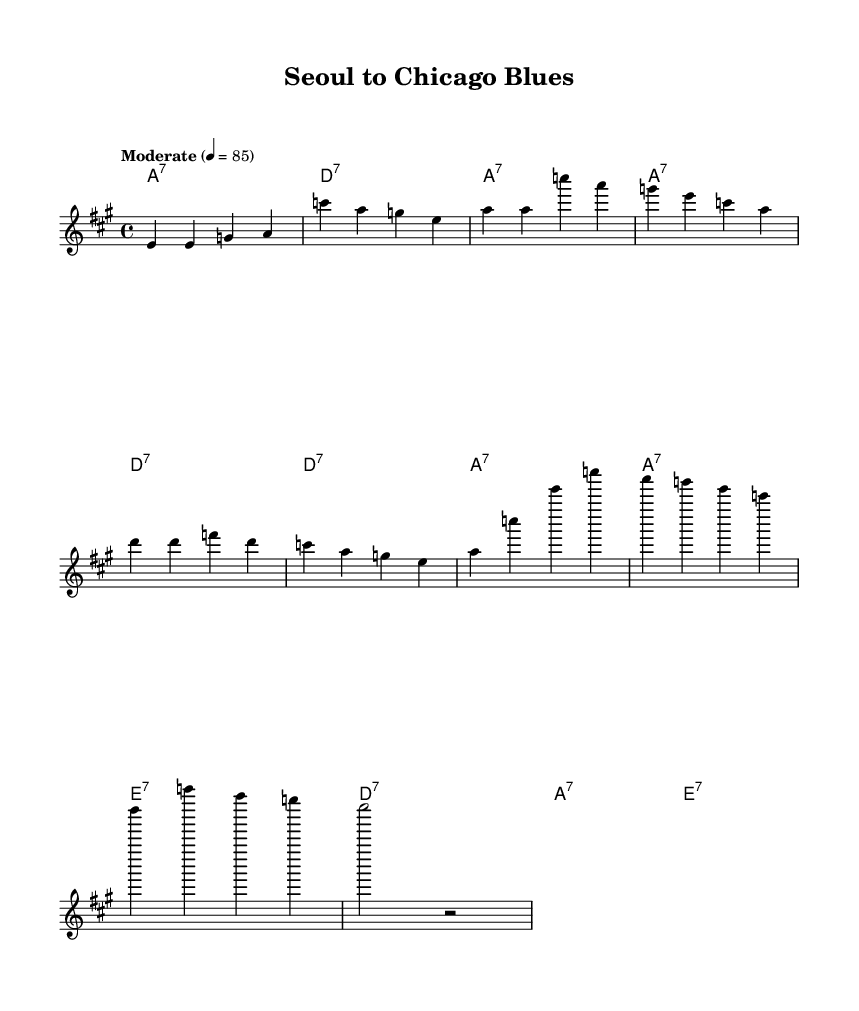What is the key signature of this music? The key signature is indicated in the global block of the code, which states "\key a \major." This means that there are three sharps in the key of A major.
Answer: A major What is the time signature of this piece? The time signature is also defined in the global block, specified as "\time 4/4." This indicates that there are four beats in a measure, and the quarter note gets one beat.
Answer: 4/4 What is the tempo marking for the music? The tempo is specified as "Moderate" with a beats per minute (BPM) marking of "4 = 85." This indicates how fast the music should be played, with 85 beats per minute.
Answer: 85 How many measures are in the chorus section? By counting the measures in the chorus lyrics section, we can see the total. "Chi -- ca -- go blues..." and the other lines make up four measures of music.
Answer: 4 What is the primary lyrical theme of the song? The lyrics express themes of displacement and perseverance, highlighting the challenges of urban life in Chicago while reflecting on a journey from Seoul. This is evident in both verses and the chorus content.
Answer: Urban life hardships What type of chord progression is used in the harmonies? The chord progression follows the typical twelve-bar blues format, alternating between A7, D7, and E7 chords. This is characteristic of the blues genre, often featuring dominant seventh chords that create a sense of tension and resolution.
Answer: Twelve-bar blues How does the melody relate to the lyrics? The melody is constructed to match the rhythmic phrasing of the lyrics, aligning syllables with notes. Each segment of lyrics corresponds to specific melodic phrases, facilitating expression in line with the blues musical style.
Answer: Matches the lyrics 